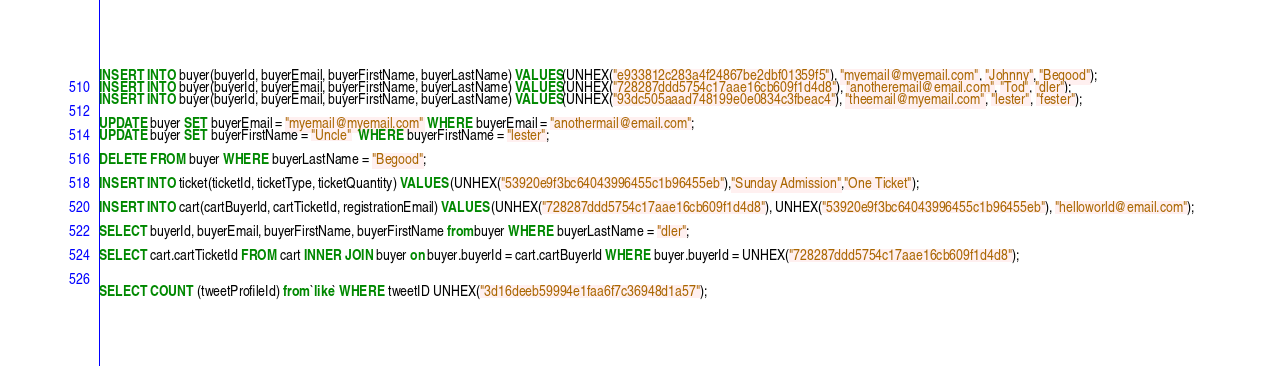Convert code to text. <code><loc_0><loc_0><loc_500><loc_500><_SQL_>INSERT INTO buyer(buyerId, buyerEmail, buyerFirstName, buyerLastName) VALUES(UNHEX("e933812c283a4f24867be2dbf01359f5"), "myemail@myemail.com", "Johnny", "Begood");
INSERT INTO buyer(buyerId, buyerEmail, buyerFirstName, buyerLastName) VALUES(UNHEX("728287ddd5754c17aae16cb609f1d4d8"), "anotheremail@email.com", "Tod", "dler");
INSERT INTO buyer(buyerId, buyerEmail, buyerFirstName, buyerLastName) VALUES(UNHEX("93dc505aaad748199e0e0834c3fbeac4"), "theemail@myemail.com", "lester", "fester");

UPDATE buyer SET buyerEmail = "myemail@myemail.com" WHERE buyerEmail = "anothermail@email.com";
UPDATE buyer SET buyerFirstName = "Uncle"  WHERE buyerFirstName = "lester";

DELETE FROM buyer WHERE buyerLastName = "Begood";

INSERT INTO ticket(ticketId, ticketType, ticketQuantity) VALUES (UNHEX("53920e9f3bc64043996455c1b96455eb"),"Sunday Admission","One Ticket");

INSERT INTO cart(cartBuyerId, cartTicketId, registrationEmail) VALUES (UNHEX("728287ddd5754c17aae16cb609f1d4d8"), UNHEX("53920e9f3bc64043996455c1b96455eb"), "helloworld@email.com");

SELECT buyerId, buyerEmail, buyerFirstName, buyerFirstName from buyer WHERE buyerLastName = "dler";

SELECT cart.cartTicketId FROM cart INNER JOIN buyer on buyer.buyerId = cart.cartBuyerId WHERE buyer.buyerId = UNHEX("728287ddd5754c17aae16cb609f1d4d8");


SELECT COUNT (tweetProfileId) from `like` WHERE tweetID UNHEX("3d16deeb59994e1faa6f7c36948d1a57");
</code> 